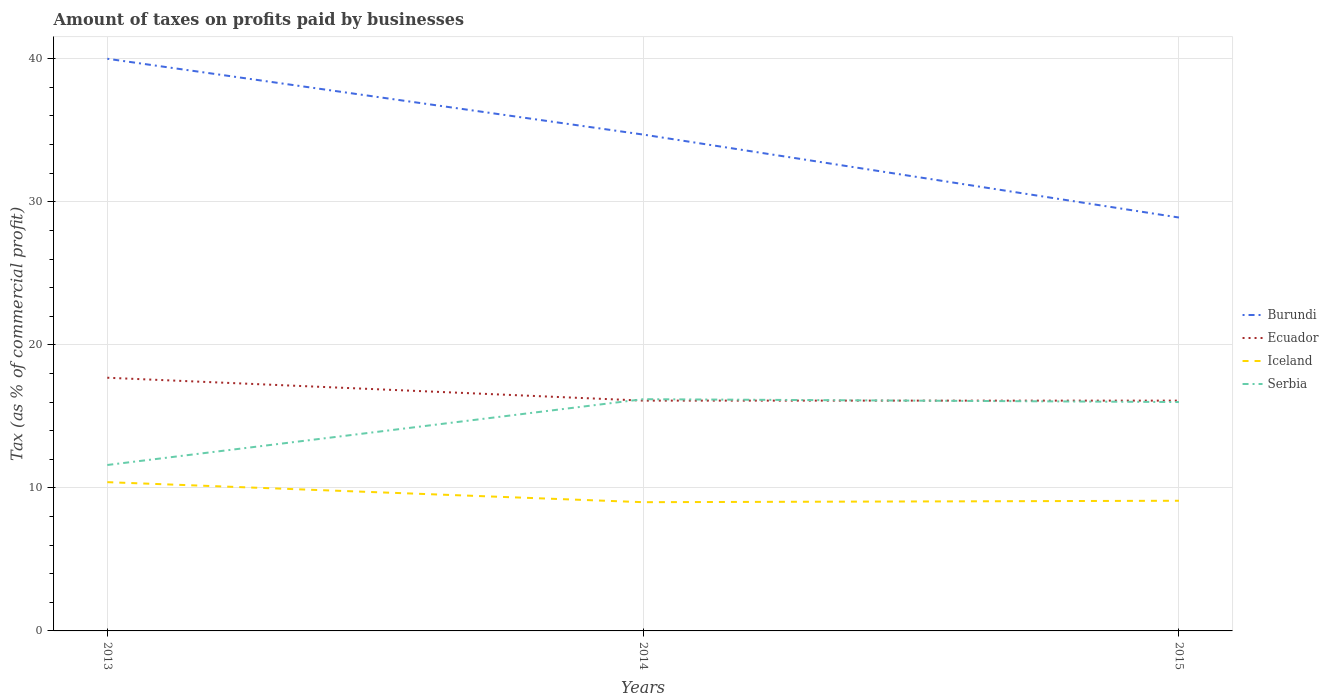How many different coloured lines are there?
Your answer should be compact. 4. Does the line corresponding to Burundi intersect with the line corresponding to Iceland?
Your response must be concise. No. Across all years, what is the maximum percentage of taxes paid by businesses in Serbia?
Make the answer very short. 11.6. In which year was the percentage of taxes paid by businesses in Serbia maximum?
Provide a succinct answer. 2013. What is the total percentage of taxes paid by businesses in Serbia in the graph?
Your answer should be very brief. 0.2. What is the difference between the highest and the second highest percentage of taxes paid by businesses in Ecuador?
Your answer should be very brief. 1.6. Are the values on the major ticks of Y-axis written in scientific E-notation?
Offer a very short reply. No. Does the graph contain any zero values?
Your response must be concise. No. What is the title of the graph?
Your answer should be compact. Amount of taxes on profits paid by businesses. What is the label or title of the X-axis?
Ensure brevity in your answer.  Years. What is the label or title of the Y-axis?
Offer a very short reply. Tax (as % of commercial profit). What is the Tax (as % of commercial profit) in Iceland in 2013?
Offer a very short reply. 10.4. What is the Tax (as % of commercial profit) in Burundi in 2014?
Offer a terse response. 34.7. What is the Tax (as % of commercial profit) of Iceland in 2014?
Ensure brevity in your answer.  9. What is the Tax (as % of commercial profit) of Burundi in 2015?
Keep it short and to the point. 28.9. What is the Tax (as % of commercial profit) of Ecuador in 2015?
Give a very brief answer. 16.1. Across all years, what is the minimum Tax (as % of commercial profit) of Burundi?
Offer a terse response. 28.9. Across all years, what is the minimum Tax (as % of commercial profit) of Ecuador?
Make the answer very short. 16.1. Across all years, what is the minimum Tax (as % of commercial profit) in Iceland?
Your response must be concise. 9. Across all years, what is the minimum Tax (as % of commercial profit) in Serbia?
Give a very brief answer. 11.6. What is the total Tax (as % of commercial profit) in Burundi in the graph?
Provide a succinct answer. 103.6. What is the total Tax (as % of commercial profit) in Ecuador in the graph?
Your answer should be compact. 49.9. What is the total Tax (as % of commercial profit) in Iceland in the graph?
Provide a succinct answer. 28.5. What is the total Tax (as % of commercial profit) in Serbia in the graph?
Your answer should be compact. 43.8. What is the difference between the Tax (as % of commercial profit) in Ecuador in 2013 and that in 2014?
Make the answer very short. 1.6. What is the difference between the Tax (as % of commercial profit) of Iceland in 2013 and that in 2014?
Provide a succinct answer. 1.4. What is the difference between the Tax (as % of commercial profit) in Iceland in 2013 and that in 2015?
Make the answer very short. 1.3. What is the difference between the Tax (as % of commercial profit) of Serbia in 2013 and that in 2015?
Ensure brevity in your answer.  -4.4. What is the difference between the Tax (as % of commercial profit) in Burundi in 2013 and the Tax (as % of commercial profit) in Ecuador in 2014?
Provide a short and direct response. 23.9. What is the difference between the Tax (as % of commercial profit) in Burundi in 2013 and the Tax (as % of commercial profit) in Iceland in 2014?
Keep it short and to the point. 31. What is the difference between the Tax (as % of commercial profit) in Burundi in 2013 and the Tax (as % of commercial profit) in Serbia in 2014?
Keep it short and to the point. 23.8. What is the difference between the Tax (as % of commercial profit) of Ecuador in 2013 and the Tax (as % of commercial profit) of Serbia in 2014?
Keep it short and to the point. 1.5. What is the difference between the Tax (as % of commercial profit) in Iceland in 2013 and the Tax (as % of commercial profit) in Serbia in 2014?
Provide a succinct answer. -5.8. What is the difference between the Tax (as % of commercial profit) in Burundi in 2013 and the Tax (as % of commercial profit) in Ecuador in 2015?
Your answer should be compact. 23.9. What is the difference between the Tax (as % of commercial profit) of Burundi in 2013 and the Tax (as % of commercial profit) of Iceland in 2015?
Offer a very short reply. 30.9. What is the difference between the Tax (as % of commercial profit) in Ecuador in 2013 and the Tax (as % of commercial profit) in Serbia in 2015?
Your response must be concise. 1.7. What is the difference between the Tax (as % of commercial profit) of Burundi in 2014 and the Tax (as % of commercial profit) of Ecuador in 2015?
Your answer should be very brief. 18.6. What is the difference between the Tax (as % of commercial profit) of Burundi in 2014 and the Tax (as % of commercial profit) of Iceland in 2015?
Ensure brevity in your answer.  25.6. What is the difference between the Tax (as % of commercial profit) in Ecuador in 2014 and the Tax (as % of commercial profit) in Iceland in 2015?
Ensure brevity in your answer.  7. What is the average Tax (as % of commercial profit) of Burundi per year?
Offer a terse response. 34.53. What is the average Tax (as % of commercial profit) in Ecuador per year?
Ensure brevity in your answer.  16.63. What is the average Tax (as % of commercial profit) of Serbia per year?
Give a very brief answer. 14.6. In the year 2013, what is the difference between the Tax (as % of commercial profit) in Burundi and Tax (as % of commercial profit) in Ecuador?
Provide a short and direct response. 22.3. In the year 2013, what is the difference between the Tax (as % of commercial profit) in Burundi and Tax (as % of commercial profit) in Iceland?
Provide a short and direct response. 29.6. In the year 2013, what is the difference between the Tax (as % of commercial profit) of Burundi and Tax (as % of commercial profit) of Serbia?
Give a very brief answer. 28.4. In the year 2013, what is the difference between the Tax (as % of commercial profit) in Ecuador and Tax (as % of commercial profit) in Iceland?
Your answer should be very brief. 7.3. In the year 2013, what is the difference between the Tax (as % of commercial profit) of Ecuador and Tax (as % of commercial profit) of Serbia?
Your answer should be compact. 6.1. In the year 2013, what is the difference between the Tax (as % of commercial profit) of Iceland and Tax (as % of commercial profit) of Serbia?
Make the answer very short. -1.2. In the year 2014, what is the difference between the Tax (as % of commercial profit) in Burundi and Tax (as % of commercial profit) in Ecuador?
Your answer should be very brief. 18.6. In the year 2014, what is the difference between the Tax (as % of commercial profit) in Burundi and Tax (as % of commercial profit) in Iceland?
Your response must be concise. 25.7. In the year 2014, what is the difference between the Tax (as % of commercial profit) of Burundi and Tax (as % of commercial profit) of Serbia?
Offer a terse response. 18.5. In the year 2014, what is the difference between the Tax (as % of commercial profit) in Ecuador and Tax (as % of commercial profit) in Serbia?
Provide a short and direct response. -0.1. In the year 2014, what is the difference between the Tax (as % of commercial profit) of Iceland and Tax (as % of commercial profit) of Serbia?
Your answer should be very brief. -7.2. In the year 2015, what is the difference between the Tax (as % of commercial profit) of Burundi and Tax (as % of commercial profit) of Ecuador?
Your answer should be very brief. 12.8. In the year 2015, what is the difference between the Tax (as % of commercial profit) in Burundi and Tax (as % of commercial profit) in Iceland?
Offer a terse response. 19.8. In the year 2015, what is the difference between the Tax (as % of commercial profit) in Ecuador and Tax (as % of commercial profit) in Iceland?
Provide a short and direct response. 7. In the year 2015, what is the difference between the Tax (as % of commercial profit) in Iceland and Tax (as % of commercial profit) in Serbia?
Keep it short and to the point. -6.9. What is the ratio of the Tax (as % of commercial profit) of Burundi in 2013 to that in 2014?
Keep it short and to the point. 1.15. What is the ratio of the Tax (as % of commercial profit) of Ecuador in 2013 to that in 2014?
Give a very brief answer. 1.1. What is the ratio of the Tax (as % of commercial profit) in Iceland in 2013 to that in 2014?
Provide a succinct answer. 1.16. What is the ratio of the Tax (as % of commercial profit) of Serbia in 2013 to that in 2014?
Provide a succinct answer. 0.72. What is the ratio of the Tax (as % of commercial profit) in Burundi in 2013 to that in 2015?
Ensure brevity in your answer.  1.38. What is the ratio of the Tax (as % of commercial profit) of Ecuador in 2013 to that in 2015?
Offer a terse response. 1.1. What is the ratio of the Tax (as % of commercial profit) in Serbia in 2013 to that in 2015?
Ensure brevity in your answer.  0.72. What is the ratio of the Tax (as % of commercial profit) in Burundi in 2014 to that in 2015?
Your response must be concise. 1.2. What is the ratio of the Tax (as % of commercial profit) in Serbia in 2014 to that in 2015?
Provide a short and direct response. 1.01. What is the difference between the highest and the second highest Tax (as % of commercial profit) of Burundi?
Offer a terse response. 5.3. What is the difference between the highest and the second highest Tax (as % of commercial profit) of Ecuador?
Your answer should be compact. 1.6. What is the difference between the highest and the lowest Tax (as % of commercial profit) of Ecuador?
Ensure brevity in your answer.  1.6. What is the difference between the highest and the lowest Tax (as % of commercial profit) of Iceland?
Make the answer very short. 1.4. What is the difference between the highest and the lowest Tax (as % of commercial profit) in Serbia?
Provide a short and direct response. 4.6. 